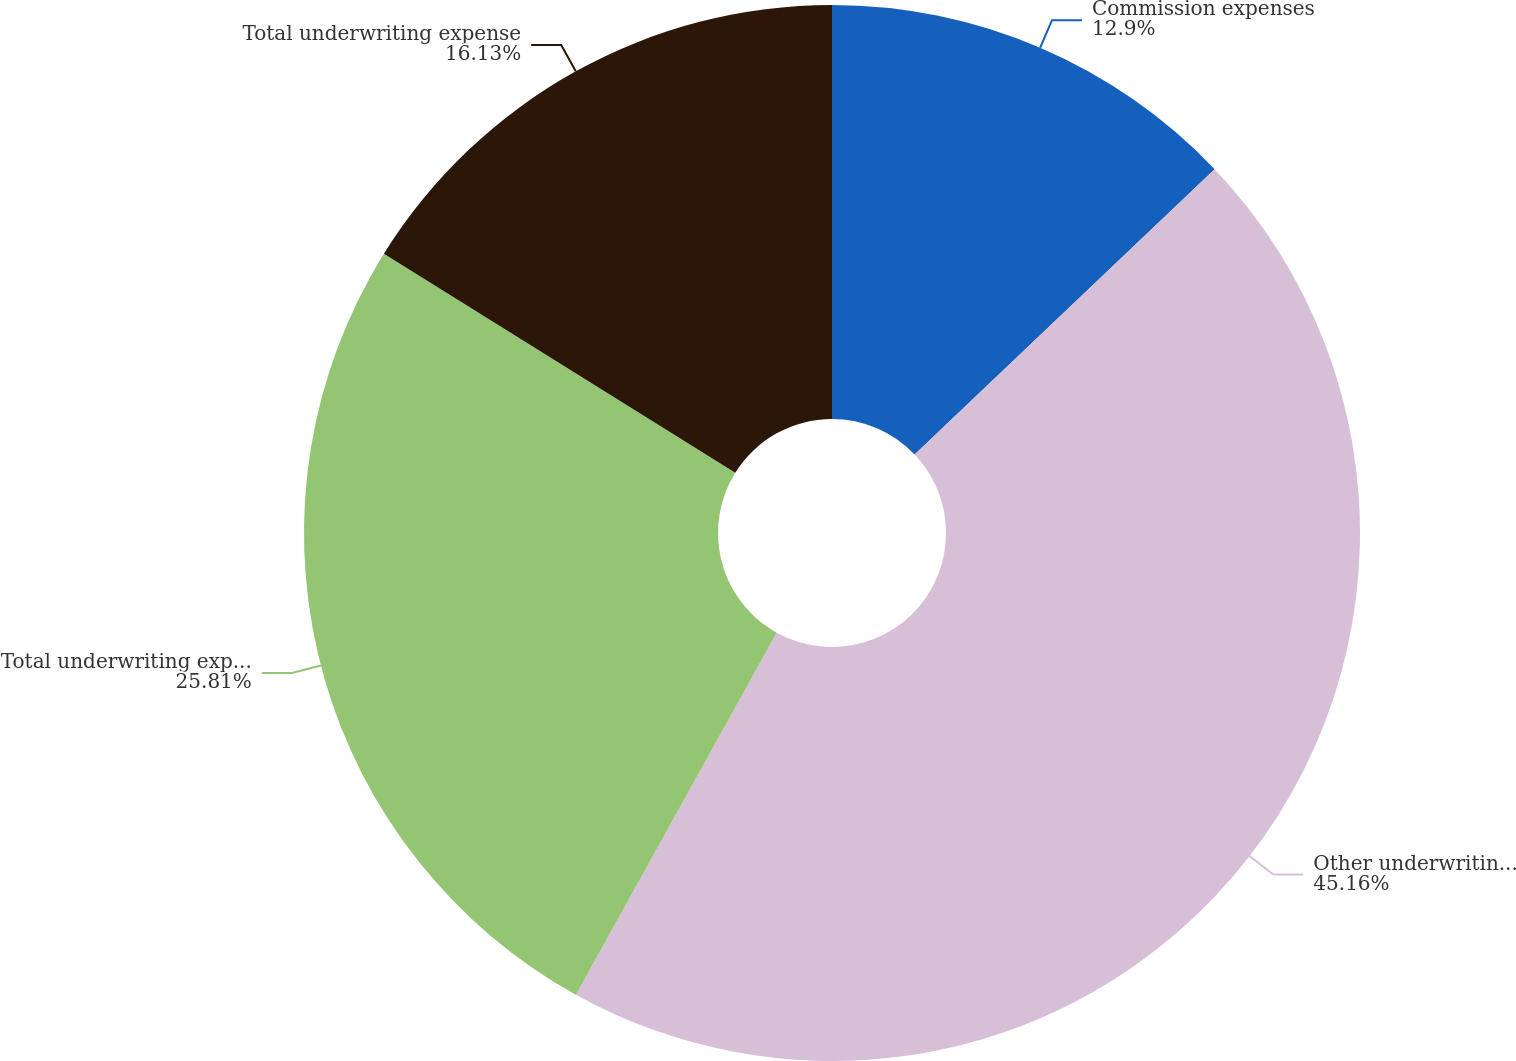Convert chart. <chart><loc_0><loc_0><loc_500><loc_500><pie_chart><fcel>Commission expenses<fcel>Other underwriting expenses<fcel>Total underwriting expenses<fcel>Total underwriting expense<nl><fcel>12.9%<fcel>45.16%<fcel>25.81%<fcel>16.13%<nl></chart> 